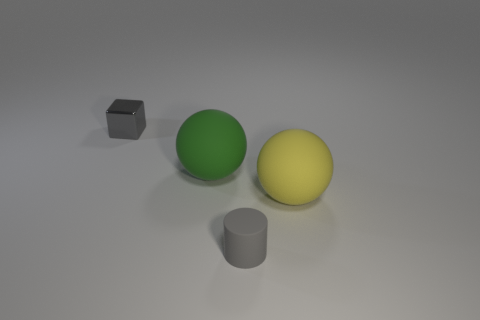What size is the matte cylinder that is the same color as the small metallic cube?
Ensure brevity in your answer.  Small. How many things are right of the gray block and behind the yellow matte sphere?
Offer a very short reply. 1. What material is the big thing that is behind the yellow rubber thing?
Your answer should be compact. Rubber. How many big things are the same color as the small rubber object?
Give a very brief answer. 0. What is the size of the other ball that is the same material as the large green ball?
Give a very brief answer. Large. What number of objects are either big rubber balls or large gray blocks?
Keep it short and to the point. 2. There is a big ball that is in front of the large green thing; what is its color?
Provide a succinct answer. Yellow. The yellow rubber thing that is the same shape as the big green rubber thing is what size?
Your response must be concise. Large. What number of objects are either metallic cubes on the left side of the gray cylinder or matte spheres left of the yellow sphere?
Offer a terse response. 2. What is the size of the matte thing that is on the left side of the yellow object and behind the matte cylinder?
Your answer should be compact. Large. 